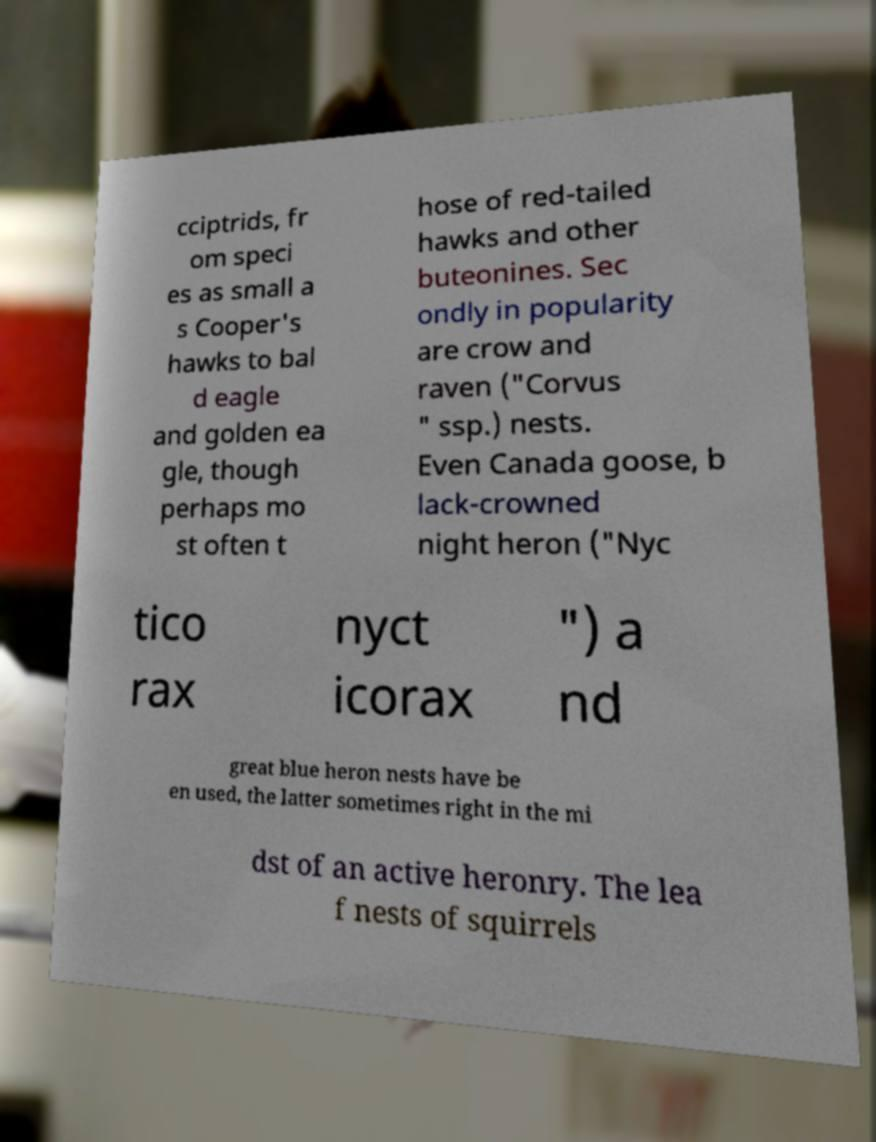Please read and relay the text visible in this image. What does it say? cciptrids, fr om speci es as small a s Cooper's hawks to bal d eagle and golden ea gle, though perhaps mo st often t hose of red-tailed hawks and other buteonines. Sec ondly in popularity are crow and raven ("Corvus " ssp.) nests. Even Canada goose, b lack-crowned night heron ("Nyc tico rax nyct icorax ") a nd great blue heron nests have be en used, the latter sometimes right in the mi dst of an active heronry. The lea f nests of squirrels 